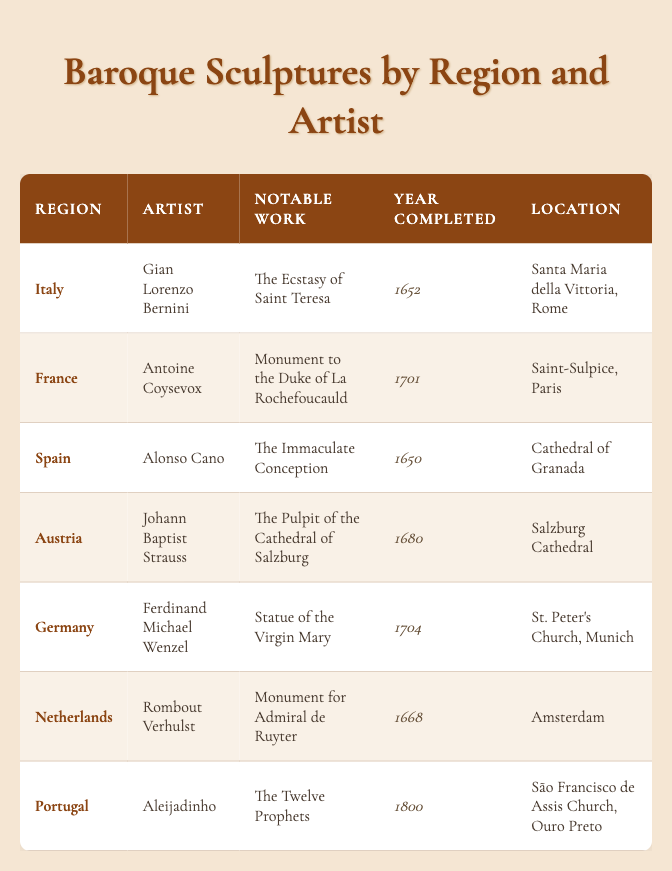What is the notable work of Gian Lorenzo Bernini? According to the table, Gian Lorenzo Bernini's notable work is "The Ecstasy of Saint Teresa."
Answer: The Ecstasy of Saint Teresa Which artist created the "Monument for Admiral de Ruyter"? The table shows that Rombout Verhulst created the "Monument for Admiral de Ruyter."
Answer: Rombout Verhulst Are there any sculptures completed in the 1700s? Looking at the table, the sculpture "Monument to the Duke of La Rochefoucauld" was completed in 1701, which confirms that there is at least one sculpture from the 1700s.
Answer: Yes Which sculpture is the oldest, and what year was it completed? To determine the oldest sculpture, we can compare the years listed in the table. "The Immaculate Conception" by Alonso Cano was completed in 1650, and "The Ecstasy of Saint Teresa" by Bernini followed in 1652. Thus, "The Immaculate Conception" is the oldest sculpture completed in 1650.
Answer: The Immaculate Conception, 1650 Which region has the most artworks listed in the table? By counting the number of sculptures associated with each region in the table, we find that Italy has one sculpture, France has one, Spain has one, Austria has one, Germany has one, Netherlands has one, and Portugal has one. Each region has an equal representation at one sculpture; hence, no region has more than another.
Answer: None; all regions have one sculpture 